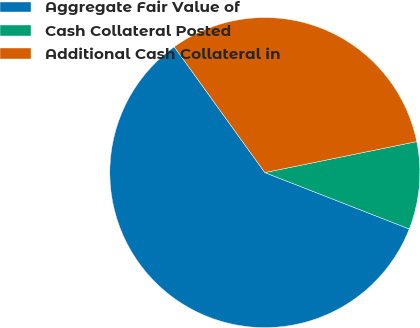Convert chart. <chart><loc_0><loc_0><loc_500><loc_500><pie_chart><fcel>Aggregate Fair Value of<fcel>Cash Collateral Posted<fcel>Additional Cash Collateral in<nl><fcel>59.13%<fcel>9.13%<fcel>31.73%<nl></chart> 